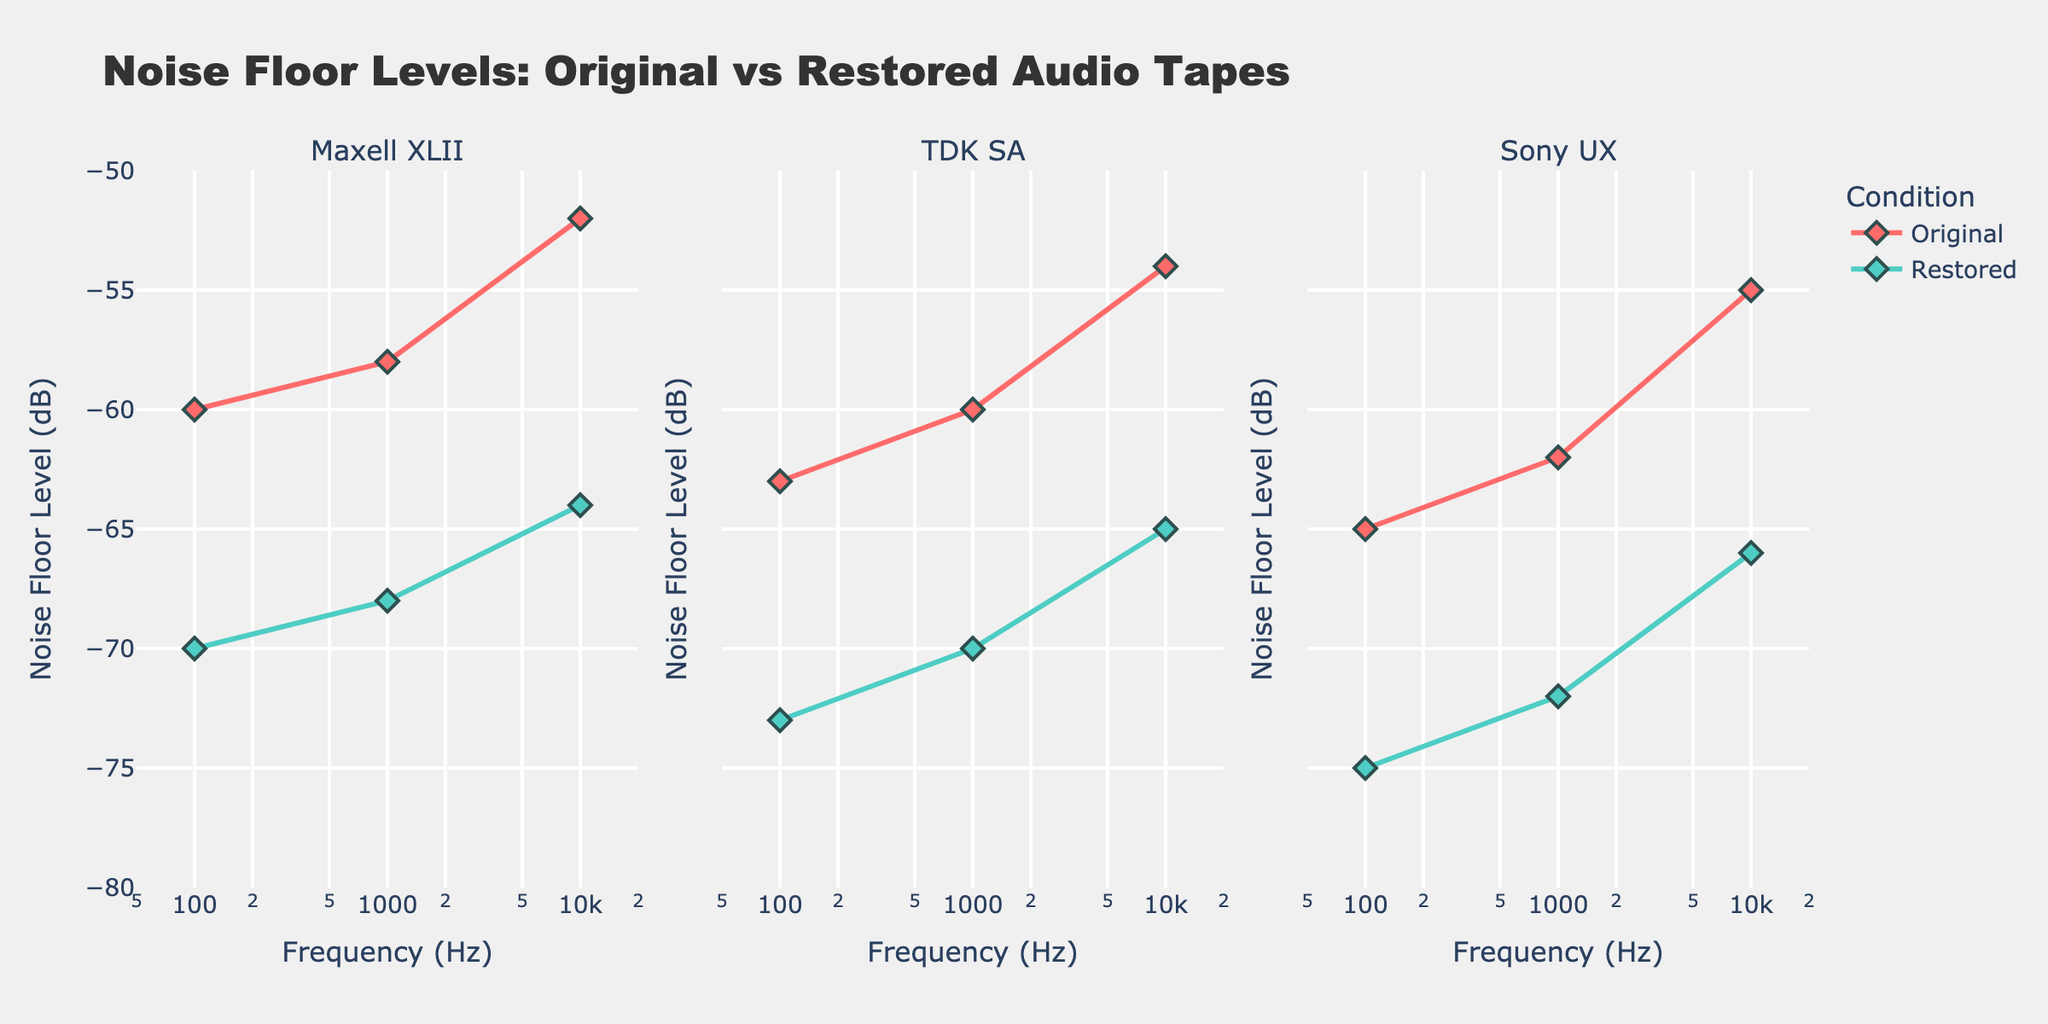What's the title of the figure? The title of the figure is stated at the top, presenting what the plot is about.
Answer: Noise Floor Levels: Original vs Restored Audio Tapes What is the axis range for Frequency (Hz)? The x-axis represents the frequency on a logarithmic scale, ranging from 50 Hz to 20000 Hz.
Answer: 50 to 20000 Hz How many subplots are there, and what do they represent? There are three subplots, each representing different audio tapes (Maxell XLII, TDK SA, Sony UX).
Answer: 3 subplots representing Maxell XLII, TDK SA, Sony UX What color is used for the 'Restored' condition? The 'Restored' condition is represented by a greenish color as indicated in the legend.
Answer: Greenish Which tape shows the largest decrease in noise floor level at 100 Hz between the original and restored conditions? By comparing the noise floor levels at 100 Hz for each tape, we can see that the restored condition shows the greatest decrease for the Sony UX tape, from -65 dB to -75 dB, a difference of 10 dB.
Answer: Sony UX On the TDK SA subplot, what is the noise floor level at 1000 Hz for both conditions? For the TDK SA tape at 1000 Hz, the noise floor level is -60 dB for the original condition and -70 dB for the restored condition.
Answer: Original: -60 dB, Restored: -70 dB How much improvement in noise floor level does the Maxell XLII tape exhibit at 10000 Hz? For the Maxell XLII tape at 10000 Hz, the original noise floor level is -52 dB, and the restored noise floor level is -64 dB. The improvement is therefore -52 - (-64) = 12 dB.
Answer: 12 dB For which frequency do all tapes show the greatest improvement in the noise floor level? Observing the improvements at 100 Hz, 1000 Hz, and 10000 Hz, the greatest improvements are found consistently at 10000 Hz for all tapes.
Answer: 10000 Hz Considering all three tapes, which one shows the greatest average improvement in noise floor level across all frequencies? Calculating the average improvement for each tape by the differences at each frequency: Maxell XLII (10+10+12)/3 = 10.67 dB, TDK SA (10+10+11)/3 ≈ 10.33 dB, Sony UX (10+10+11)/3 ≈ 10.33 dB. Maxell XLII shows the greatest average improvement.
Answer: Maxell XLII 